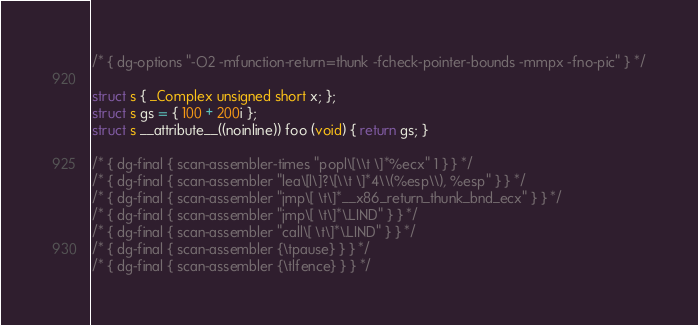Convert code to text. <code><loc_0><loc_0><loc_500><loc_500><_C_>/* { dg-options "-O2 -mfunction-return=thunk -fcheck-pointer-bounds -mmpx -fno-pic" } */

struct s { _Complex unsigned short x; };
struct s gs = { 100 + 200i };
struct s __attribute__((noinline)) foo (void) { return gs; }

/* { dg-final { scan-assembler-times "popl\[\\t \]*%ecx" 1 } } */
/* { dg-final { scan-assembler "lea\[l\]?\[\\t \]*4\\(%esp\\), %esp" } } */
/* { dg-final { scan-assembler "jmp\[ \t\]*__x86_return_thunk_bnd_ecx" } } */
/* { dg-final { scan-assembler "jmp\[ \t\]*\.LIND" } } */
/* { dg-final { scan-assembler "call\[ \t\]*\.LIND" } } */
/* { dg-final { scan-assembler {\tpause} } } */
/* { dg-final { scan-assembler {\tlfence} } } */
</code> 